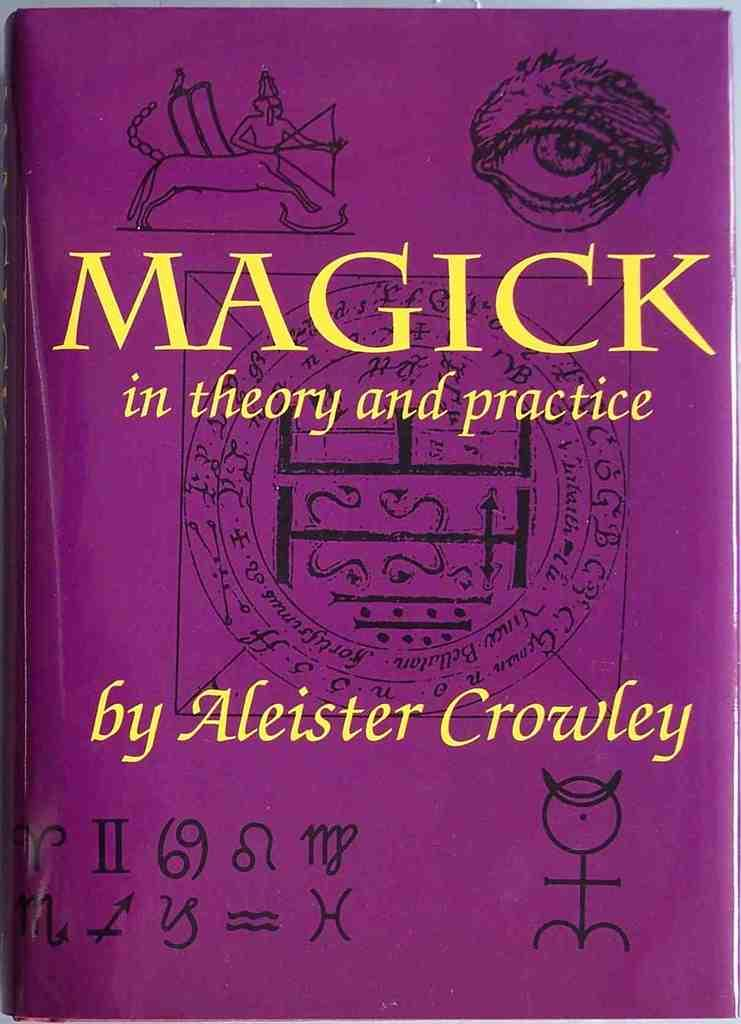Provide a one-sentence caption for the provided image. A copy of the book Magick by Aleister Crowley. 